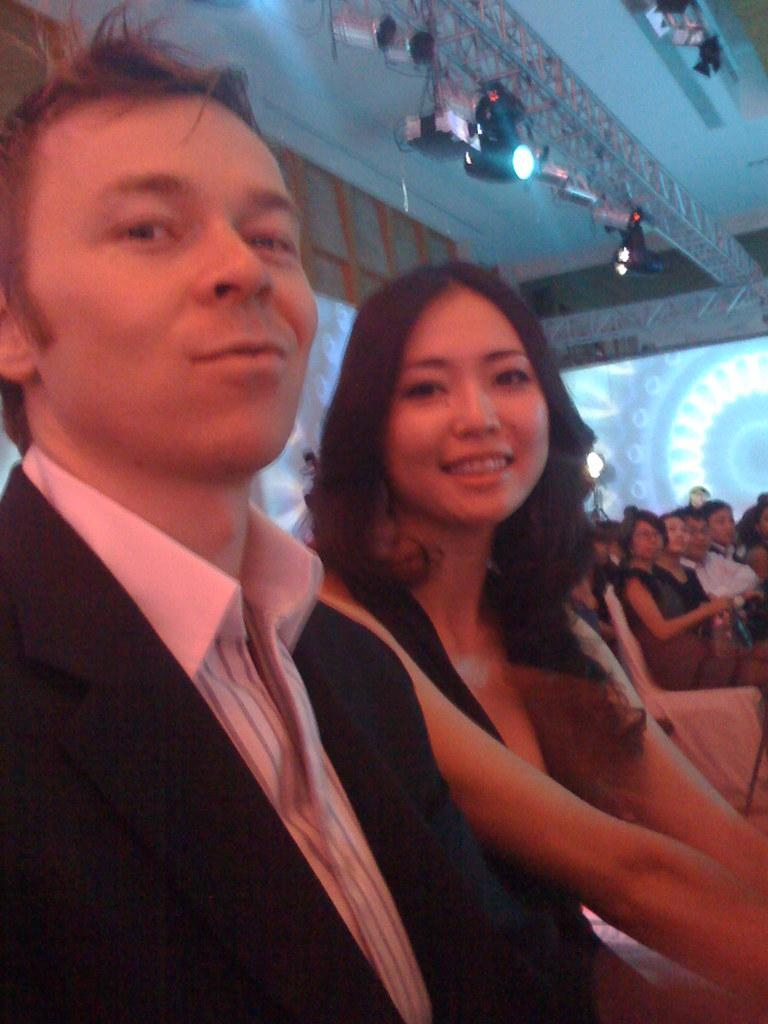What are the people in the image doing? The persons in the image are sitting on chairs. What can be seen on the pillars in the image? There are lights on pillars in the image. What type of dress is the minister wearing in the image? There is no minister or dress present in the image. 